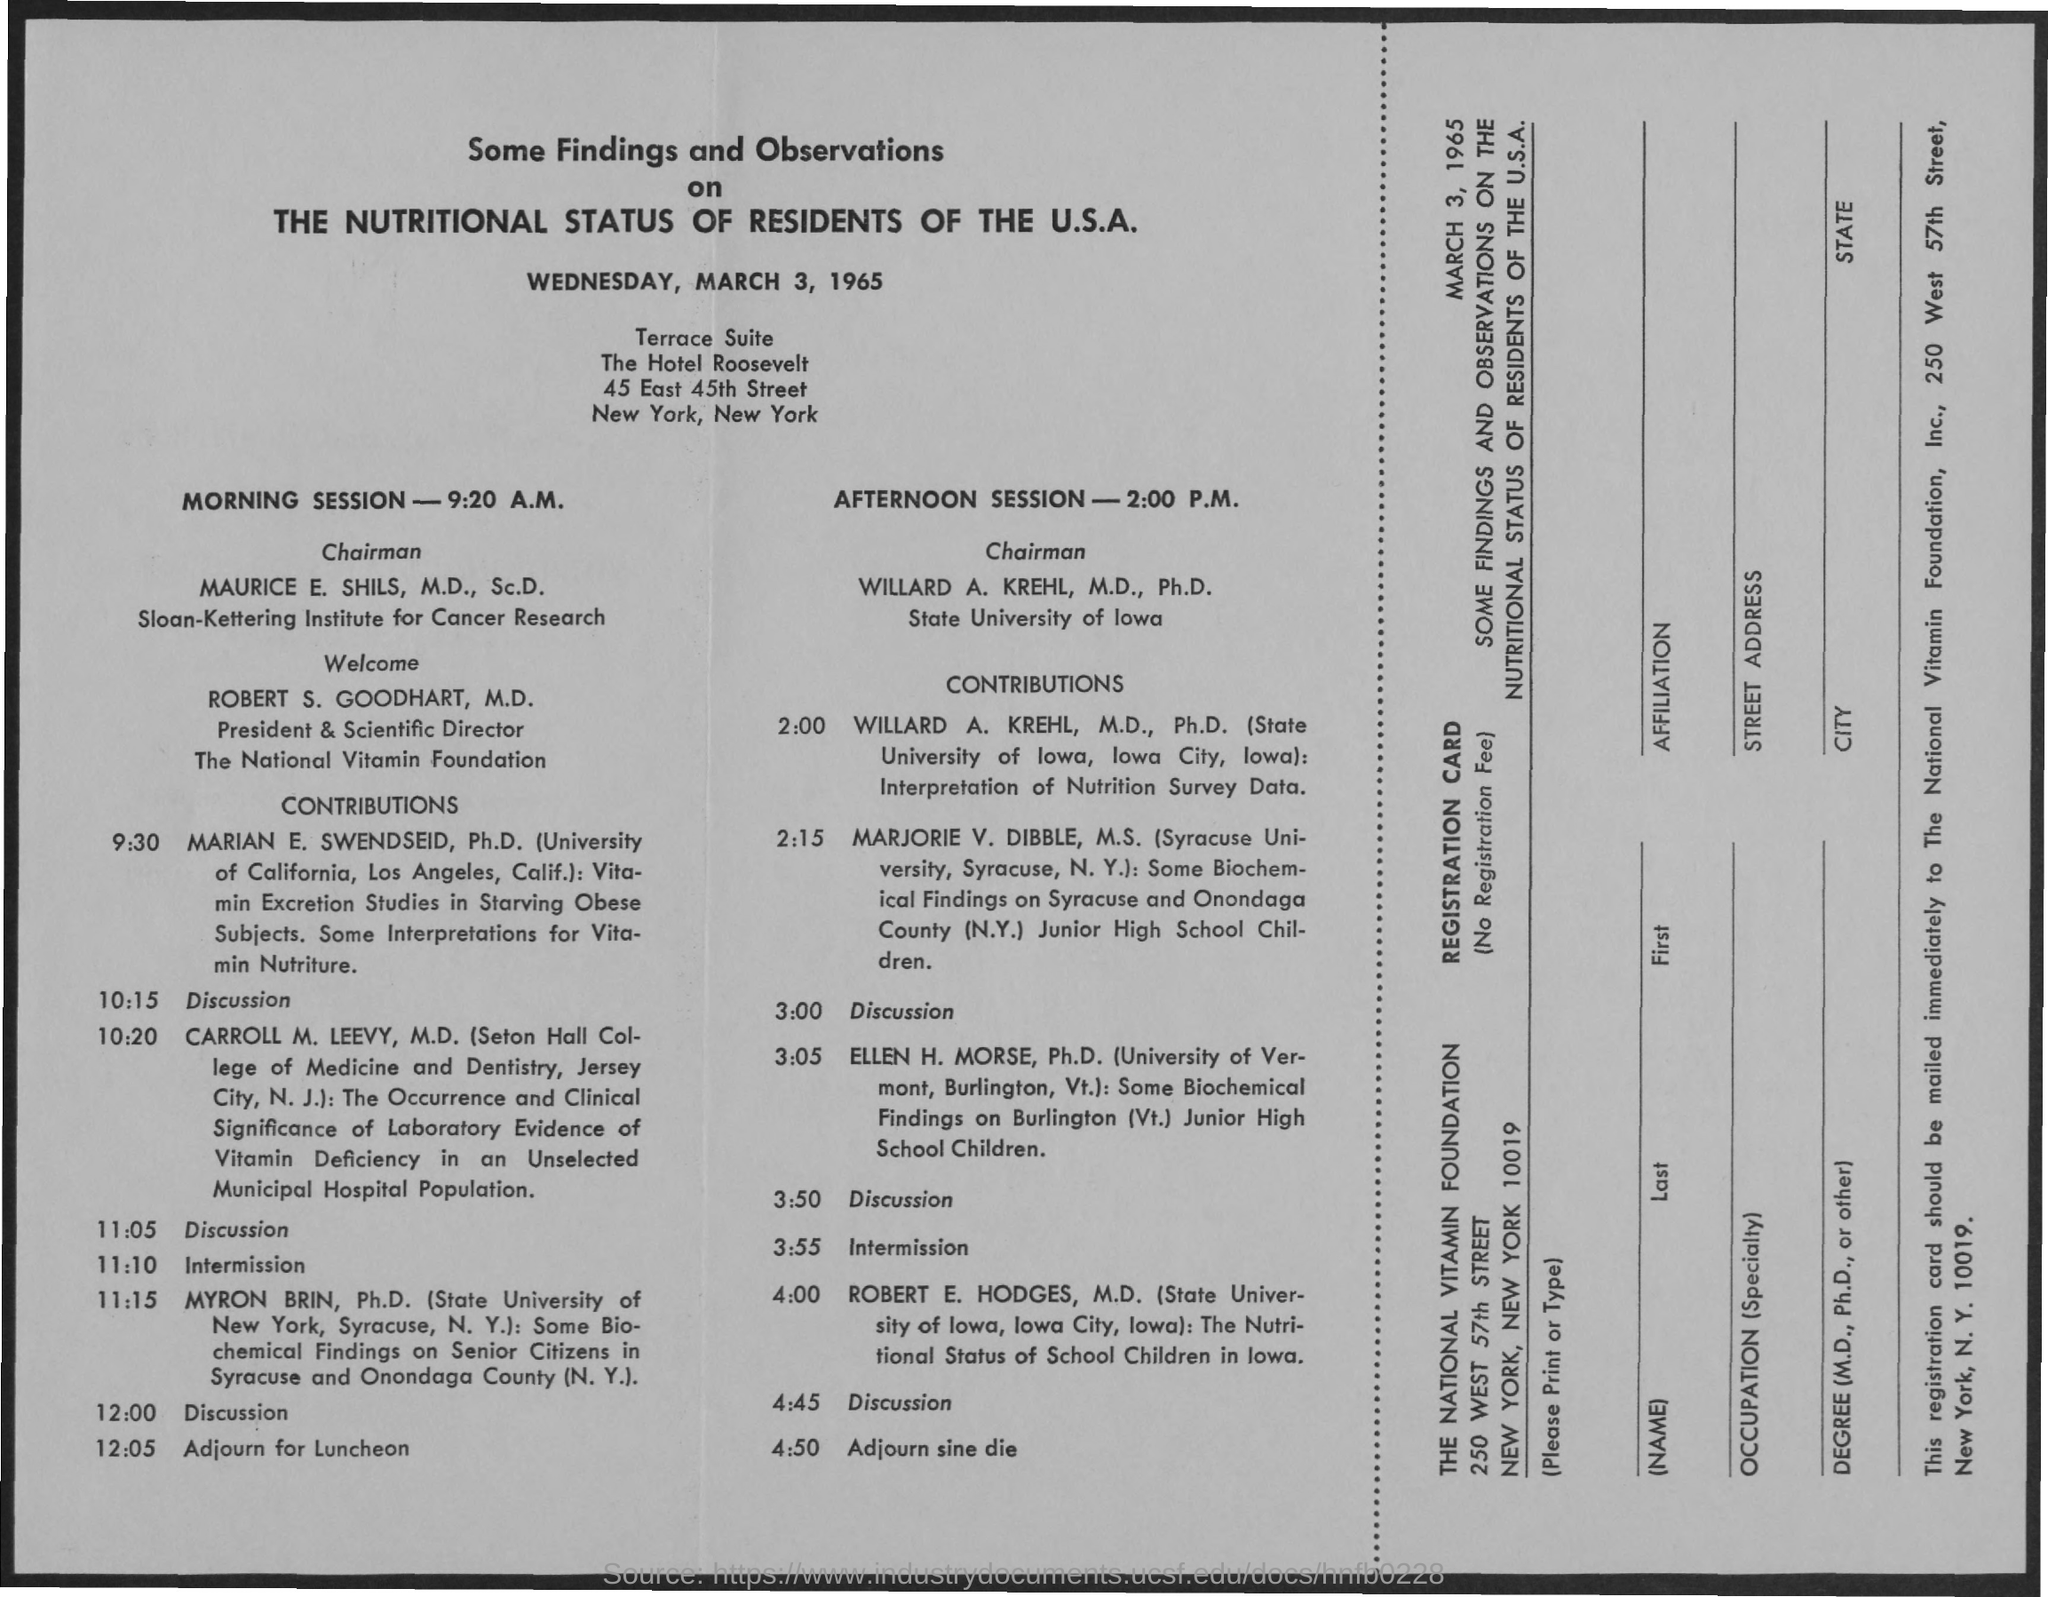What is the date mentioned in the document?
Your response must be concise. Wednesday, March 3, 1965. 